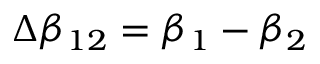Convert formula to latex. <formula><loc_0><loc_0><loc_500><loc_500>\Delta \beta _ { 1 2 } = \beta _ { 1 } - \beta _ { 2 }</formula> 